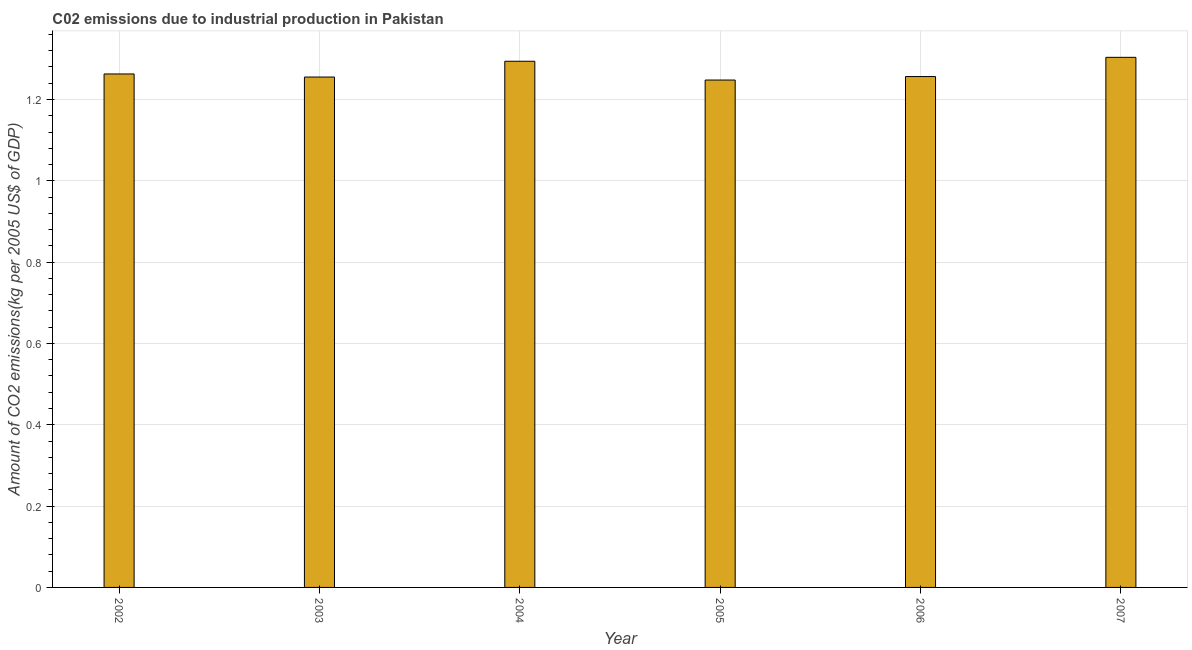Does the graph contain grids?
Your response must be concise. Yes. What is the title of the graph?
Keep it short and to the point. C02 emissions due to industrial production in Pakistan. What is the label or title of the Y-axis?
Your answer should be very brief. Amount of CO2 emissions(kg per 2005 US$ of GDP). What is the amount of co2 emissions in 2006?
Ensure brevity in your answer.  1.26. Across all years, what is the maximum amount of co2 emissions?
Provide a short and direct response. 1.3. Across all years, what is the minimum amount of co2 emissions?
Keep it short and to the point. 1.25. In which year was the amount of co2 emissions minimum?
Provide a short and direct response. 2005. What is the sum of the amount of co2 emissions?
Your response must be concise. 7.62. What is the difference between the amount of co2 emissions in 2004 and 2007?
Offer a terse response. -0.01. What is the average amount of co2 emissions per year?
Offer a terse response. 1.27. What is the median amount of co2 emissions?
Provide a succinct answer. 1.26. In how many years, is the amount of co2 emissions greater than 1 kg per 2005 US$ of GDP?
Give a very brief answer. 6. Is the amount of co2 emissions in 2003 less than that in 2005?
Make the answer very short. No. Is the sum of the amount of co2 emissions in 2003 and 2004 greater than the maximum amount of co2 emissions across all years?
Offer a terse response. Yes. What is the difference between the highest and the lowest amount of co2 emissions?
Your answer should be very brief. 0.06. How many years are there in the graph?
Provide a short and direct response. 6. What is the difference between two consecutive major ticks on the Y-axis?
Your answer should be compact. 0.2. What is the Amount of CO2 emissions(kg per 2005 US$ of GDP) of 2002?
Provide a succinct answer. 1.26. What is the Amount of CO2 emissions(kg per 2005 US$ of GDP) in 2003?
Provide a short and direct response. 1.26. What is the Amount of CO2 emissions(kg per 2005 US$ of GDP) of 2004?
Make the answer very short. 1.29. What is the Amount of CO2 emissions(kg per 2005 US$ of GDP) in 2005?
Keep it short and to the point. 1.25. What is the Amount of CO2 emissions(kg per 2005 US$ of GDP) of 2006?
Your answer should be compact. 1.26. What is the Amount of CO2 emissions(kg per 2005 US$ of GDP) in 2007?
Offer a very short reply. 1.3. What is the difference between the Amount of CO2 emissions(kg per 2005 US$ of GDP) in 2002 and 2003?
Provide a succinct answer. 0.01. What is the difference between the Amount of CO2 emissions(kg per 2005 US$ of GDP) in 2002 and 2004?
Your answer should be very brief. -0.03. What is the difference between the Amount of CO2 emissions(kg per 2005 US$ of GDP) in 2002 and 2005?
Keep it short and to the point. 0.01. What is the difference between the Amount of CO2 emissions(kg per 2005 US$ of GDP) in 2002 and 2006?
Ensure brevity in your answer.  0.01. What is the difference between the Amount of CO2 emissions(kg per 2005 US$ of GDP) in 2002 and 2007?
Provide a succinct answer. -0.04. What is the difference between the Amount of CO2 emissions(kg per 2005 US$ of GDP) in 2003 and 2004?
Your answer should be very brief. -0.04. What is the difference between the Amount of CO2 emissions(kg per 2005 US$ of GDP) in 2003 and 2005?
Make the answer very short. 0.01. What is the difference between the Amount of CO2 emissions(kg per 2005 US$ of GDP) in 2003 and 2006?
Your answer should be very brief. -0. What is the difference between the Amount of CO2 emissions(kg per 2005 US$ of GDP) in 2003 and 2007?
Offer a very short reply. -0.05. What is the difference between the Amount of CO2 emissions(kg per 2005 US$ of GDP) in 2004 and 2005?
Make the answer very short. 0.05. What is the difference between the Amount of CO2 emissions(kg per 2005 US$ of GDP) in 2004 and 2006?
Give a very brief answer. 0.04. What is the difference between the Amount of CO2 emissions(kg per 2005 US$ of GDP) in 2004 and 2007?
Offer a very short reply. -0.01. What is the difference between the Amount of CO2 emissions(kg per 2005 US$ of GDP) in 2005 and 2006?
Provide a short and direct response. -0.01. What is the difference between the Amount of CO2 emissions(kg per 2005 US$ of GDP) in 2005 and 2007?
Offer a very short reply. -0.06. What is the difference between the Amount of CO2 emissions(kg per 2005 US$ of GDP) in 2006 and 2007?
Make the answer very short. -0.05. What is the ratio of the Amount of CO2 emissions(kg per 2005 US$ of GDP) in 2002 to that in 2003?
Keep it short and to the point. 1.01. What is the ratio of the Amount of CO2 emissions(kg per 2005 US$ of GDP) in 2002 to that in 2005?
Provide a succinct answer. 1.01. What is the ratio of the Amount of CO2 emissions(kg per 2005 US$ of GDP) in 2002 to that in 2007?
Offer a very short reply. 0.97. What is the ratio of the Amount of CO2 emissions(kg per 2005 US$ of GDP) in 2003 to that in 2004?
Your response must be concise. 0.97. What is the ratio of the Amount of CO2 emissions(kg per 2005 US$ of GDP) in 2003 to that in 2005?
Your response must be concise. 1.01. What is the ratio of the Amount of CO2 emissions(kg per 2005 US$ of GDP) in 2003 to that in 2007?
Your answer should be compact. 0.96. What is the ratio of the Amount of CO2 emissions(kg per 2005 US$ of GDP) in 2005 to that in 2006?
Provide a short and direct response. 0.99. What is the ratio of the Amount of CO2 emissions(kg per 2005 US$ of GDP) in 2006 to that in 2007?
Give a very brief answer. 0.96. 